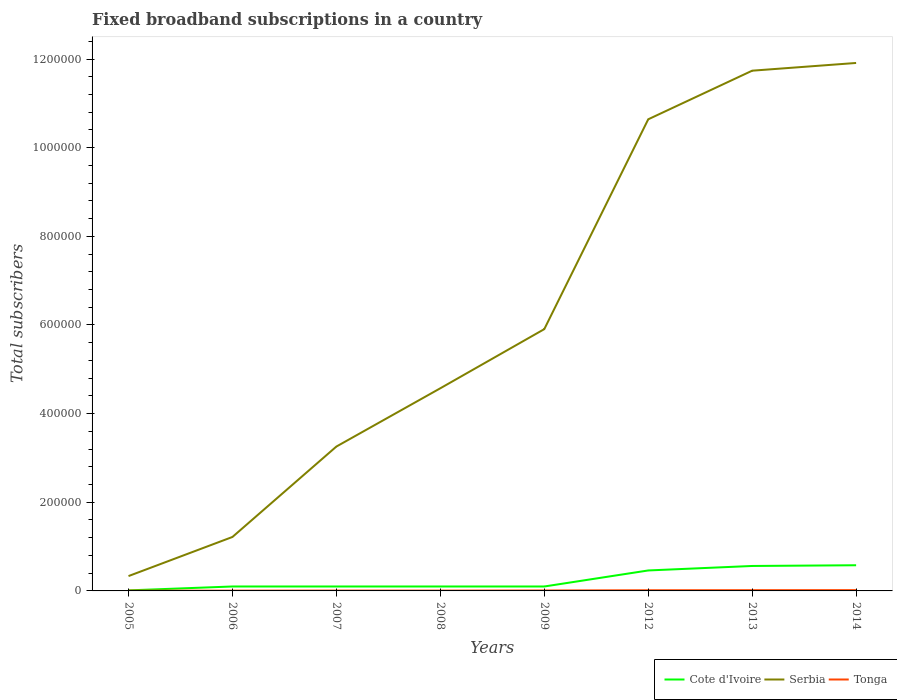How many different coloured lines are there?
Offer a terse response. 3. Across all years, what is the maximum number of broadband subscriptions in Cote d'Ivoire?
Ensure brevity in your answer.  1239. In which year was the number of broadband subscriptions in Tonga maximum?
Give a very brief answer. 2006. What is the total number of broadband subscriptions in Serbia in the graph?
Offer a very short reply. -7.16e+05. What is the difference between the highest and the second highest number of broadband subscriptions in Cote d'Ivoire?
Ensure brevity in your answer.  5.67e+04. What is the difference between the highest and the lowest number of broadband subscriptions in Serbia?
Make the answer very short. 3. How are the legend labels stacked?
Provide a succinct answer. Horizontal. What is the title of the graph?
Your answer should be very brief. Fixed broadband subscriptions in a country. What is the label or title of the Y-axis?
Give a very brief answer. Total subscribers. What is the Total subscribers of Cote d'Ivoire in 2005?
Provide a short and direct response. 1239. What is the Total subscribers in Serbia in 2005?
Provide a succinct answer. 3.35e+04. What is the Total subscribers of Tonga in 2005?
Offer a very short reply. 645. What is the Total subscribers of Cote d'Ivoire in 2006?
Give a very brief answer. 10000. What is the Total subscribers in Serbia in 2006?
Your answer should be very brief. 1.22e+05. What is the Total subscribers of Tonga in 2006?
Give a very brief answer. 633. What is the Total subscribers in Cote d'Ivoire in 2007?
Offer a very short reply. 10000. What is the Total subscribers in Serbia in 2007?
Your response must be concise. 3.26e+05. What is the Total subscribers in Tonga in 2007?
Your response must be concise. 780. What is the Total subscribers of Serbia in 2008?
Keep it short and to the point. 4.57e+05. What is the Total subscribers in Tonga in 2008?
Make the answer very short. 721. What is the Total subscribers of Serbia in 2009?
Your response must be concise. 5.91e+05. What is the Total subscribers in Tonga in 2009?
Make the answer very short. 1000. What is the Total subscribers in Cote d'Ivoire in 2012?
Your answer should be compact. 4.62e+04. What is the Total subscribers in Serbia in 2012?
Your response must be concise. 1.06e+06. What is the Total subscribers of Tonga in 2012?
Offer a very short reply. 1500. What is the Total subscribers in Cote d'Ivoire in 2013?
Give a very brief answer. 5.63e+04. What is the Total subscribers of Serbia in 2013?
Ensure brevity in your answer.  1.17e+06. What is the Total subscribers in Tonga in 2013?
Provide a succinct answer. 1700. What is the Total subscribers of Cote d'Ivoire in 2014?
Make the answer very short. 5.79e+04. What is the Total subscribers in Serbia in 2014?
Provide a short and direct response. 1.19e+06. What is the Total subscribers of Tonga in 2014?
Your answer should be compact. 1800. Across all years, what is the maximum Total subscribers in Cote d'Ivoire?
Your response must be concise. 5.79e+04. Across all years, what is the maximum Total subscribers in Serbia?
Ensure brevity in your answer.  1.19e+06. Across all years, what is the maximum Total subscribers in Tonga?
Give a very brief answer. 1800. Across all years, what is the minimum Total subscribers in Cote d'Ivoire?
Give a very brief answer. 1239. Across all years, what is the minimum Total subscribers in Serbia?
Provide a short and direct response. 3.35e+04. Across all years, what is the minimum Total subscribers in Tonga?
Your response must be concise. 633. What is the total Total subscribers of Cote d'Ivoire in the graph?
Keep it short and to the point. 2.02e+05. What is the total Total subscribers of Serbia in the graph?
Keep it short and to the point. 4.96e+06. What is the total Total subscribers in Tonga in the graph?
Ensure brevity in your answer.  8779. What is the difference between the Total subscribers of Cote d'Ivoire in 2005 and that in 2006?
Provide a succinct answer. -8761. What is the difference between the Total subscribers in Serbia in 2005 and that in 2006?
Your answer should be compact. -8.82e+04. What is the difference between the Total subscribers in Cote d'Ivoire in 2005 and that in 2007?
Keep it short and to the point. -8761. What is the difference between the Total subscribers in Serbia in 2005 and that in 2007?
Your response must be concise. -2.92e+05. What is the difference between the Total subscribers in Tonga in 2005 and that in 2007?
Your answer should be compact. -135. What is the difference between the Total subscribers in Cote d'Ivoire in 2005 and that in 2008?
Offer a very short reply. -8761. What is the difference between the Total subscribers of Serbia in 2005 and that in 2008?
Ensure brevity in your answer.  -4.24e+05. What is the difference between the Total subscribers of Tonga in 2005 and that in 2008?
Keep it short and to the point. -76. What is the difference between the Total subscribers in Cote d'Ivoire in 2005 and that in 2009?
Your answer should be very brief. -8761. What is the difference between the Total subscribers in Serbia in 2005 and that in 2009?
Your answer should be very brief. -5.57e+05. What is the difference between the Total subscribers in Tonga in 2005 and that in 2009?
Provide a succinct answer. -355. What is the difference between the Total subscribers of Cote d'Ivoire in 2005 and that in 2012?
Provide a short and direct response. -4.49e+04. What is the difference between the Total subscribers of Serbia in 2005 and that in 2012?
Keep it short and to the point. -1.03e+06. What is the difference between the Total subscribers of Tonga in 2005 and that in 2012?
Provide a short and direct response. -855. What is the difference between the Total subscribers in Cote d'Ivoire in 2005 and that in 2013?
Your answer should be compact. -5.50e+04. What is the difference between the Total subscribers in Serbia in 2005 and that in 2013?
Provide a succinct answer. -1.14e+06. What is the difference between the Total subscribers of Tonga in 2005 and that in 2013?
Provide a short and direct response. -1055. What is the difference between the Total subscribers in Cote d'Ivoire in 2005 and that in 2014?
Give a very brief answer. -5.67e+04. What is the difference between the Total subscribers in Serbia in 2005 and that in 2014?
Your response must be concise. -1.16e+06. What is the difference between the Total subscribers of Tonga in 2005 and that in 2014?
Offer a very short reply. -1155. What is the difference between the Total subscribers of Serbia in 2006 and that in 2007?
Your answer should be compact. -2.04e+05. What is the difference between the Total subscribers of Tonga in 2006 and that in 2007?
Keep it short and to the point. -147. What is the difference between the Total subscribers in Cote d'Ivoire in 2006 and that in 2008?
Offer a terse response. 0. What is the difference between the Total subscribers in Serbia in 2006 and that in 2008?
Give a very brief answer. -3.35e+05. What is the difference between the Total subscribers of Tonga in 2006 and that in 2008?
Offer a terse response. -88. What is the difference between the Total subscribers of Serbia in 2006 and that in 2009?
Make the answer very short. -4.69e+05. What is the difference between the Total subscribers of Tonga in 2006 and that in 2009?
Your answer should be very brief. -367. What is the difference between the Total subscribers of Cote d'Ivoire in 2006 and that in 2012?
Provide a succinct answer. -3.62e+04. What is the difference between the Total subscribers of Serbia in 2006 and that in 2012?
Your response must be concise. -9.42e+05. What is the difference between the Total subscribers of Tonga in 2006 and that in 2012?
Give a very brief answer. -867. What is the difference between the Total subscribers in Cote d'Ivoire in 2006 and that in 2013?
Offer a terse response. -4.63e+04. What is the difference between the Total subscribers in Serbia in 2006 and that in 2013?
Make the answer very short. -1.05e+06. What is the difference between the Total subscribers of Tonga in 2006 and that in 2013?
Your answer should be very brief. -1067. What is the difference between the Total subscribers of Cote d'Ivoire in 2006 and that in 2014?
Your answer should be compact. -4.79e+04. What is the difference between the Total subscribers in Serbia in 2006 and that in 2014?
Provide a short and direct response. -1.07e+06. What is the difference between the Total subscribers in Tonga in 2006 and that in 2014?
Your response must be concise. -1167. What is the difference between the Total subscribers in Serbia in 2007 and that in 2008?
Make the answer very short. -1.31e+05. What is the difference between the Total subscribers in Cote d'Ivoire in 2007 and that in 2009?
Your response must be concise. 0. What is the difference between the Total subscribers of Serbia in 2007 and that in 2009?
Give a very brief answer. -2.65e+05. What is the difference between the Total subscribers of Tonga in 2007 and that in 2009?
Keep it short and to the point. -220. What is the difference between the Total subscribers in Cote d'Ivoire in 2007 and that in 2012?
Offer a very short reply. -3.62e+04. What is the difference between the Total subscribers in Serbia in 2007 and that in 2012?
Provide a succinct answer. -7.38e+05. What is the difference between the Total subscribers of Tonga in 2007 and that in 2012?
Make the answer very short. -720. What is the difference between the Total subscribers in Cote d'Ivoire in 2007 and that in 2013?
Give a very brief answer. -4.63e+04. What is the difference between the Total subscribers of Serbia in 2007 and that in 2013?
Your answer should be very brief. -8.48e+05. What is the difference between the Total subscribers of Tonga in 2007 and that in 2013?
Offer a terse response. -920. What is the difference between the Total subscribers in Cote d'Ivoire in 2007 and that in 2014?
Your answer should be compact. -4.79e+04. What is the difference between the Total subscribers of Serbia in 2007 and that in 2014?
Provide a succinct answer. -8.65e+05. What is the difference between the Total subscribers of Tonga in 2007 and that in 2014?
Make the answer very short. -1020. What is the difference between the Total subscribers in Serbia in 2008 and that in 2009?
Ensure brevity in your answer.  -1.33e+05. What is the difference between the Total subscribers of Tonga in 2008 and that in 2009?
Your answer should be compact. -279. What is the difference between the Total subscribers in Cote d'Ivoire in 2008 and that in 2012?
Make the answer very short. -3.62e+04. What is the difference between the Total subscribers of Serbia in 2008 and that in 2012?
Keep it short and to the point. -6.07e+05. What is the difference between the Total subscribers in Tonga in 2008 and that in 2012?
Your answer should be compact. -779. What is the difference between the Total subscribers in Cote d'Ivoire in 2008 and that in 2013?
Keep it short and to the point. -4.63e+04. What is the difference between the Total subscribers of Serbia in 2008 and that in 2013?
Give a very brief answer. -7.16e+05. What is the difference between the Total subscribers of Tonga in 2008 and that in 2013?
Ensure brevity in your answer.  -979. What is the difference between the Total subscribers of Cote d'Ivoire in 2008 and that in 2014?
Ensure brevity in your answer.  -4.79e+04. What is the difference between the Total subscribers in Serbia in 2008 and that in 2014?
Give a very brief answer. -7.34e+05. What is the difference between the Total subscribers of Tonga in 2008 and that in 2014?
Give a very brief answer. -1079. What is the difference between the Total subscribers of Cote d'Ivoire in 2009 and that in 2012?
Offer a very short reply. -3.62e+04. What is the difference between the Total subscribers of Serbia in 2009 and that in 2012?
Make the answer very short. -4.73e+05. What is the difference between the Total subscribers of Tonga in 2009 and that in 2012?
Provide a succinct answer. -500. What is the difference between the Total subscribers of Cote d'Ivoire in 2009 and that in 2013?
Provide a short and direct response. -4.63e+04. What is the difference between the Total subscribers of Serbia in 2009 and that in 2013?
Your answer should be compact. -5.83e+05. What is the difference between the Total subscribers in Tonga in 2009 and that in 2013?
Offer a very short reply. -700. What is the difference between the Total subscribers of Cote d'Ivoire in 2009 and that in 2014?
Ensure brevity in your answer.  -4.79e+04. What is the difference between the Total subscribers in Serbia in 2009 and that in 2014?
Your answer should be compact. -6.00e+05. What is the difference between the Total subscribers of Tonga in 2009 and that in 2014?
Your response must be concise. -800. What is the difference between the Total subscribers in Cote d'Ivoire in 2012 and that in 2013?
Your response must be concise. -1.01e+04. What is the difference between the Total subscribers in Serbia in 2012 and that in 2013?
Provide a short and direct response. -1.10e+05. What is the difference between the Total subscribers in Tonga in 2012 and that in 2013?
Give a very brief answer. -200. What is the difference between the Total subscribers of Cote d'Ivoire in 2012 and that in 2014?
Offer a very short reply. -1.17e+04. What is the difference between the Total subscribers of Serbia in 2012 and that in 2014?
Offer a very short reply. -1.27e+05. What is the difference between the Total subscribers of Tonga in 2012 and that in 2014?
Provide a succinct answer. -300. What is the difference between the Total subscribers of Cote d'Ivoire in 2013 and that in 2014?
Provide a short and direct response. -1633. What is the difference between the Total subscribers of Serbia in 2013 and that in 2014?
Your response must be concise. -1.74e+04. What is the difference between the Total subscribers in Tonga in 2013 and that in 2014?
Your answer should be very brief. -100. What is the difference between the Total subscribers in Cote d'Ivoire in 2005 and the Total subscribers in Serbia in 2006?
Your answer should be compact. -1.20e+05. What is the difference between the Total subscribers in Cote d'Ivoire in 2005 and the Total subscribers in Tonga in 2006?
Offer a very short reply. 606. What is the difference between the Total subscribers in Serbia in 2005 and the Total subscribers in Tonga in 2006?
Offer a terse response. 3.29e+04. What is the difference between the Total subscribers of Cote d'Ivoire in 2005 and the Total subscribers of Serbia in 2007?
Keep it short and to the point. -3.24e+05. What is the difference between the Total subscribers of Cote d'Ivoire in 2005 and the Total subscribers of Tonga in 2007?
Offer a terse response. 459. What is the difference between the Total subscribers of Serbia in 2005 and the Total subscribers of Tonga in 2007?
Your answer should be very brief. 3.27e+04. What is the difference between the Total subscribers of Cote d'Ivoire in 2005 and the Total subscribers of Serbia in 2008?
Give a very brief answer. -4.56e+05. What is the difference between the Total subscribers in Cote d'Ivoire in 2005 and the Total subscribers in Tonga in 2008?
Your response must be concise. 518. What is the difference between the Total subscribers of Serbia in 2005 and the Total subscribers of Tonga in 2008?
Ensure brevity in your answer.  3.28e+04. What is the difference between the Total subscribers of Cote d'Ivoire in 2005 and the Total subscribers of Serbia in 2009?
Make the answer very short. -5.89e+05. What is the difference between the Total subscribers of Cote d'Ivoire in 2005 and the Total subscribers of Tonga in 2009?
Offer a terse response. 239. What is the difference between the Total subscribers of Serbia in 2005 and the Total subscribers of Tonga in 2009?
Provide a short and direct response. 3.25e+04. What is the difference between the Total subscribers of Cote d'Ivoire in 2005 and the Total subscribers of Serbia in 2012?
Offer a very short reply. -1.06e+06. What is the difference between the Total subscribers in Cote d'Ivoire in 2005 and the Total subscribers in Tonga in 2012?
Offer a terse response. -261. What is the difference between the Total subscribers of Serbia in 2005 and the Total subscribers of Tonga in 2012?
Your answer should be very brief. 3.20e+04. What is the difference between the Total subscribers in Cote d'Ivoire in 2005 and the Total subscribers in Serbia in 2013?
Your response must be concise. -1.17e+06. What is the difference between the Total subscribers in Cote d'Ivoire in 2005 and the Total subscribers in Tonga in 2013?
Offer a terse response. -461. What is the difference between the Total subscribers of Serbia in 2005 and the Total subscribers of Tonga in 2013?
Your answer should be very brief. 3.18e+04. What is the difference between the Total subscribers in Cote d'Ivoire in 2005 and the Total subscribers in Serbia in 2014?
Provide a short and direct response. -1.19e+06. What is the difference between the Total subscribers of Cote d'Ivoire in 2005 and the Total subscribers of Tonga in 2014?
Make the answer very short. -561. What is the difference between the Total subscribers of Serbia in 2005 and the Total subscribers of Tonga in 2014?
Give a very brief answer. 3.17e+04. What is the difference between the Total subscribers in Cote d'Ivoire in 2006 and the Total subscribers in Serbia in 2007?
Your response must be concise. -3.16e+05. What is the difference between the Total subscribers of Cote d'Ivoire in 2006 and the Total subscribers of Tonga in 2007?
Your response must be concise. 9220. What is the difference between the Total subscribers in Serbia in 2006 and the Total subscribers in Tonga in 2007?
Your response must be concise. 1.21e+05. What is the difference between the Total subscribers in Cote d'Ivoire in 2006 and the Total subscribers in Serbia in 2008?
Your answer should be very brief. -4.47e+05. What is the difference between the Total subscribers of Cote d'Ivoire in 2006 and the Total subscribers of Tonga in 2008?
Ensure brevity in your answer.  9279. What is the difference between the Total subscribers of Serbia in 2006 and the Total subscribers of Tonga in 2008?
Keep it short and to the point. 1.21e+05. What is the difference between the Total subscribers in Cote d'Ivoire in 2006 and the Total subscribers in Serbia in 2009?
Provide a succinct answer. -5.81e+05. What is the difference between the Total subscribers in Cote d'Ivoire in 2006 and the Total subscribers in Tonga in 2009?
Offer a terse response. 9000. What is the difference between the Total subscribers in Serbia in 2006 and the Total subscribers in Tonga in 2009?
Offer a very short reply. 1.21e+05. What is the difference between the Total subscribers of Cote d'Ivoire in 2006 and the Total subscribers of Serbia in 2012?
Make the answer very short. -1.05e+06. What is the difference between the Total subscribers in Cote d'Ivoire in 2006 and the Total subscribers in Tonga in 2012?
Your answer should be very brief. 8500. What is the difference between the Total subscribers of Serbia in 2006 and the Total subscribers of Tonga in 2012?
Keep it short and to the point. 1.20e+05. What is the difference between the Total subscribers in Cote d'Ivoire in 2006 and the Total subscribers in Serbia in 2013?
Offer a terse response. -1.16e+06. What is the difference between the Total subscribers in Cote d'Ivoire in 2006 and the Total subscribers in Tonga in 2013?
Keep it short and to the point. 8300. What is the difference between the Total subscribers of Serbia in 2006 and the Total subscribers of Tonga in 2013?
Offer a terse response. 1.20e+05. What is the difference between the Total subscribers in Cote d'Ivoire in 2006 and the Total subscribers in Serbia in 2014?
Provide a succinct answer. -1.18e+06. What is the difference between the Total subscribers in Cote d'Ivoire in 2006 and the Total subscribers in Tonga in 2014?
Provide a short and direct response. 8200. What is the difference between the Total subscribers of Serbia in 2006 and the Total subscribers of Tonga in 2014?
Give a very brief answer. 1.20e+05. What is the difference between the Total subscribers of Cote d'Ivoire in 2007 and the Total subscribers of Serbia in 2008?
Your answer should be very brief. -4.47e+05. What is the difference between the Total subscribers in Cote d'Ivoire in 2007 and the Total subscribers in Tonga in 2008?
Provide a succinct answer. 9279. What is the difference between the Total subscribers in Serbia in 2007 and the Total subscribers in Tonga in 2008?
Your answer should be very brief. 3.25e+05. What is the difference between the Total subscribers of Cote d'Ivoire in 2007 and the Total subscribers of Serbia in 2009?
Make the answer very short. -5.81e+05. What is the difference between the Total subscribers of Cote d'Ivoire in 2007 and the Total subscribers of Tonga in 2009?
Your response must be concise. 9000. What is the difference between the Total subscribers in Serbia in 2007 and the Total subscribers in Tonga in 2009?
Give a very brief answer. 3.25e+05. What is the difference between the Total subscribers in Cote d'Ivoire in 2007 and the Total subscribers in Serbia in 2012?
Offer a very short reply. -1.05e+06. What is the difference between the Total subscribers in Cote d'Ivoire in 2007 and the Total subscribers in Tonga in 2012?
Your answer should be compact. 8500. What is the difference between the Total subscribers of Serbia in 2007 and the Total subscribers of Tonga in 2012?
Your response must be concise. 3.24e+05. What is the difference between the Total subscribers of Cote d'Ivoire in 2007 and the Total subscribers of Serbia in 2013?
Ensure brevity in your answer.  -1.16e+06. What is the difference between the Total subscribers of Cote d'Ivoire in 2007 and the Total subscribers of Tonga in 2013?
Provide a succinct answer. 8300. What is the difference between the Total subscribers in Serbia in 2007 and the Total subscribers in Tonga in 2013?
Your answer should be compact. 3.24e+05. What is the difference between the Total subscribers of Cote d'Ivoire in 2007 and the Total subscribers of Serbia in 2014?
Your answer should be compact. -1.18e+06. What is the difference between the Total subscribers of Cote d'Ivoire in 2007 and the Total subscribers of Tonga in 2014?
Ensure brevity in your answer.  8200. What is the difference between the Total subscribers in Serbia in 2007 and the Total subscribers in Tonga in 2014?
Provide a succinct answer. 3.24e+05. What is the difference between the Total subscribers in Cote d'Ivoire in 2008 and the Total subscribers in Serbia in 2009?
Keep it short and to the point. -5.81e+05. What is the difference between the Total subscribers in Cote d'Ivoire in 2008 and the Total subscribers in Tonga in 2009?
Give a very brief answer. 9000. What is the difference between the Total subscribers of Serbia in 2008 and the Total subscribers of Tonga in 2009?
Ensure brevity in your answer.  4.56e+05. What is the difference between the Total subscribers of Cote d'Ivoire in 2008 and the Total subscribers of Serbia in 2012?
Provide a short and direct response. -1.05e+06. What is the difference between the Total subscribers in Cote d'Ivoire in 2008 and the Total subscribers in Tonga in 2012?
Provide a succinct answer. 8500. What is the difference between the Total subscribers of Serbia in 2008 and the Total subscribers of Tonga in 2012?
Offer a very short reply. 4.56e+05. What is the difference between the Total subscribers in Cote d'Ivoire in 2008 and the Total subscribers in Serbia in 2013?
Ensure brevity in your answer.  -1.16e+06. What is the difference between the Total subscribers in Cote d'Ivoire in 2008 and the Total subscribers in Tonga in 2013?
Offer a terse response. 8300. What is the difference between the Total subscribers in Serbia in 2008 and the Total subscribers in Tonga in 2013?
Give a very brief answer. 4.55e+05. What is the difference between the Total subscribers in Cote d'Ivoire in 2008 and the Total subscribers in Serbia in 2014?
Your response must be concise. -1.18e+06. What is the difference between the Total subscribers of Cote d'Ivoire in 2008 and the Total subscribers of Tonga in 2014?
Your answer should be very brief. 8200. What is the difference between the Total subscribers of Serbia in 2008 and the Total subscribers of Tonga in 2014?
Your answer should be compact. 4.55e+05. What is the difference between the Total subscribers of Cote d'Ivoire in 2009 and the Total subscribers of Serbia in 2012?
Ensure brevity in your answer.  -1.05e+06. What is the difference between the Total subscribers of Cote d'Ivoire in 2009 and the Total subscribers of Tonga in 2012?
Provide a succinct answer. 8500. What is the difference between the Total subscribers in Serbia in 2009 and the Total subscribers in Tonga in 2012?
Give a very brief answer. 5.89e+05. What is the difference between the Total subscribers in Cote d'Ivoire in 2009 and the Total subscribers in Serbia in 2013?
Give a very brief answer. -1.16e+06. What is the difference between the Total subscribers in Cote d'Ivoire in 2009 and the Total subscribers in Tonga in 2013?
Your response must be concise. 8300. What is the difference between the Total subscribers in Serbia in 2009 and the Total subscribers in Tonga in 2013?
Provide a succinct answer. 5.89e+05. What is the difference between the Total subscribers of Cote d'Ivoire in 2009 and the Total subscribers of Serbia in 2014?
Offer a very short reply. -1.18e+06. What is the difference between the Total subscribers in Cote d'Ivoire in 2009 and the Total subscribers in Tonga in 2014?
Offer a terse response. 8200. What is the difference between the Total subscribers in Serbia in 2009 and the Total subscribers in Tonga in 2014?
Your response must be concise. 5.89e+05. What is the difference between the Total subscribers in Cote d'Ivoire in 2012 and the Total subscribers in Serbia in 2013?
Make the answer very short. -1.13e+06. What is the difference between the Total subscribers in Cote d'Ivoire in 2012 and the Total subscribers in Tonga in 2013?
Your answer should be very brief. 4.45e+04. What is the difference between the Total subscribers in Serbia in 2012 and the Total subscribers in Tonga in 2013?
Your answer should be compact. 1.06e+06. What is the difference between the Total subscribers in Cote d'Ivoire in 2012 and the Total subscribers in Serbia in 2014?
Offer a terse response. -1.14e+06. What is the difference between the Total subscribers in Cote d'Ivoire in 2012 and the Total subscribers in Tonga in 2014?
Ensure brevity in your answer.  4.44e+04. What is the difference between the Total subscribers of Serbia in 2012 and the Total subscribers of Tonga in 2014?
Offer a very short reply. 1.06e+06. What is the difference between the Total subscribers in Cote d'Ivoire in 2013 and the Total subscribers in Serbia in 2014?
Offer a terse response. -1.13e+06. What is the difference between the Total subscribers in Cote d'Ivoire in 2013 and the Total subscribers in Tonga in 2014?
Provide a short and direct response. 5.45e+04. What is the difference between the Total subscribers in Serbia in 2013 and the Total subscribers in Tonga in 2014?
Give a very brief answer. 1.17e+06. What is the average Total subscribers of Cote d'Ivoire per year?
Offer a very short reply. 2.52e+04. What is the average Total subscribers in Serbia per year?
Make the answer very short. 6.20e+05. What is the average Total subscribers of Tonga per year?
Your response must be concise. 1097.38. In the year 2005, what is the difference between the Total subscribers in Cote d'Ivoire and Total subscribers in Serbia?
Your answer should be very brief. -3.22e+04. In the year 2005, what is the difference between the Total subscribers of Cote d'Ivoire and Total subscribers of Tonga?
Give a very brief answer. 594. In the year 2005, what is the difference between the Total subscribers in Serbia and Total subscribers in Tonga?
Offer a terse response. 3.28e+04. In the year 2006, what is the difference between the Total subscribers in Cote d'Ivoire and Total subscribers in Serbia?
Offer a very short reply. -1.12e+05. In the year 2006, what is the difference between the Total subscribers in Cote d'Ivoire and Total subscribers in Tonga?
Your answer should be compact. 9367. In the year 2006, what is the difference between the Total subscribers in Serbia and Total subscribers in Tonga?
Give a very brief answer. 1.21e+05. In the year 2007, what is the difference between the Total subscribers in Cote d'Ivoire and Total subscribers in Serbia?
Your answer should be compact. -3.16e+05. In the year 2007, what is the difference between the Total subscribers in Cote d'Ivoire and Total subscribers in Tonga?
Provide a succinct answer. 9220. In the year 2007, what is the difference between the Total subscribers of Serbia and Total subscribers of Tonga?
Keep it short and to the point. 3.25e+05. In the year 2008, what is the difference between the Total subscribers of Cote d'Ivoire and Total subscribers of Serbia?
Provide a succinct answer. -4.47e+05. In the year 2008, what is the difference between the Total subscribers in Cote d'Ivoire and Total subscribers in Tonga?
Your response must be concise. 9279. In the year 2008, what is the difference between the Total subscribers of Serbia and Total subscribers of Tonga?
Provide a short and direct response. 4.56e+05. In the year 2009, what is the difference between the Total subscribers in Cote d'Ivoire and Total subscribers in Serbia?
Your answer should be very brief. -5.81e+05. In the year 2009, what is the difference between the Total subscribers in Cote d'Ivoire and Total subscribers in Tonga?
Make the answer very short. 9000. In the year 2009, what is the difference between the Total subscribers in Serbia and Total subscribers in Tonga?
Your answer should be compact. 5.90e+05. In the year 2012, what is the difference between the Total subscribers in Cote d'Ivoire and Total subscribers in Serbia?
Your answer should be very brief. -1.02e+06. In the year 2012, what is the difference between the Total subscribers in Cote d'Ivoire and Total subscribers in Tonga?
Offer a terse response. 4.47e+04. In the year 2012, what is the difference between the Total subscribers in Serbia and Total subscribers in Tonga?
Keep it short and to the point. 1.06e+06. In the year 2013, what is the difference between the Total subscribers in Cote d'Ivoire and Total subscribers in Serbia?
Your answer should be compact. -1.12e+06. In the year 2013, what is the difference between the Total subscribers in Cote d'Ivoire and Total subscribers in Tonga?
Keep it short and to the point. 5.46e+04. In the year 2013, what is the difference between the Total subscribers of Serbia and Total subscribers of Tonga?
Provide a short and direct response. 1.17e+06. In the year 2014, what is the difference between the Total subscribers in Cote d'Ivoire and Total subscribers in Serbia?
Offer a terse response. -1.13e+06. In the year 2014, what is the difference between the Total subscribers of Cote d'Ivoire and Total subscribers of Tonga?
Keep it short and to the point. 5.61e+04. In the year 2014, what is the difference between the Total subscribers of Serbia and Total subscribers of Tonga?
Make the answer very short. 1.19e+06. What is the ratio of the Total subscribers of Cote d'Ivoire in 2005 to that in 2006?
Provide a short and direct response. 0.12. What is the ratio of the Total subscribers of Serbia in 2005 to that in 2006?
Offer a terse response. 0.28. What is the ratio of the Total subscribers in Tonga in 2005 to that in 2006?
Your answer should be very brief. 1.02. What is the ratio of the Total subscribers in Cote d'Ivoire in 2005 to that in 2007?
Your answer should be compact. 0.12. What is the ratio of the Total subscribers in Serbia in 2005 to that in 2007?
Your answer should be compact. 0.1. What is the ratio of the Total subscribers of Tonga in 2005 to that in 2007?
Provide a succinct answer. 0.83. What is the ratio of the Total subscribers of Cote d'Ivoire in 2005 to that in 2008?
Keep it short and to the point. 0.12. What is the ratio of the Total subscribers in Serbia in 2005 to that in 2008?
Your response must be concise. 0.07. What is the ratio of the Total subscribers in Tonga in 2005 to that in 2008?
Provide a succinct answer. 0.89. What is the ratio of the Total subscribers of Cote d'Ivoire in 2005 to that in 2009?
Make the answer very short. 0.12. What is the ratio of the Total subscribers in Serbia in 2005 to that in 2009?
Offer a very short reply. 0.06. What is the ratio of the Total subscribers of Tonga in 2005 to that in 2009?
Give a very brief answer. 0.65. What is the ratio of the Total subscribers of Cote d'Ivoire in 2005 to that in 2012?
Offer a terse response. 0.03. What is the ratio of the Total subscribers of Serbia in 2005 to that in 2012?
Your response must be concise. 0.03. What is the ratio of the Total subscribers in Tonga in 2005 to that in 2012?
Offer a very short reply. 0.43. What is the ratio of the Total subscribers in Cote d'Ivoire in 2005 to that in 2013?
Give a very brief answer. 0.02. What is the ratio of the Total subscribers of Serbia in 2005 to that in 2013?
Keep it short and to the point. 0.03. What is the ratio of the Total subscribers in Tonga in 2005 to that in 2013?
Your response must be concise. 0.38. What is the ratio of the Total subscribers in Cote d'Ivoire in 2005 to that in 2014?
Give a very brief answer. 0.02. What is the ratio of the Total subscribers of Serbia in 2005 to that in 2014?
Your response must be concise. 0.03. What is the ratio of the Total subscribers of Tonga in 2005 to that in 2014?
Keep it short and to the point. 0.36. What is the ratio of the Total subscribers of Serbia in 2006 to that in 2007?
Provide a short and direct response. 0.37. What is the ratio of the Total subscribers in Tonga in 2006 to that in 2007?
Keep it short and to the point. 0.81. What is the ratio of the Total subscribers in Serbia in 2006 to that in 2008?
Your answer should be compact. 0.27. What is the ratio of the Total subscribers of Tonga in 2006 to that in 2008?
Offer a very short reply. 0.88. What is the ratio of the Total subscribers of Serbia in 2006 to that in 2009?
Give a very brief answer. 0.21. What is the ratio of the Total subscribers of Tonga in 2006 to that in 2009?
Keep it short and to the point. 0.63. What is the ratio of the Total subscribers of Cote d'Ivoire in 2006 to that in 2012?
Your answer should be very brief. 0.22. What is the ratio of the Total subscribers in Serbia in 2006 to that in 2012?
Offer a very short reply. 0.11. What is the ratio of the Total subscribers in Tonga in 2006 to that in 2012?
Give a very brief answer. 0.42. What is the ratio of the Total subscribers of Cote d'Ivoire in 2006 to that in 2013?
Provide a succinct answer. 0.18. What is the ratio of the Total subscribers in Serbia in 2006 to that in 2013?
Make the answer very short. 0.1. What is the ratio of the Total subscribers of Tonga in 2006 to that in 2013?
Give a very brief answer. 0.37. What is the ratio of the Total subscribers of Cote d'Ivoire in 2006 to that in 2014?
Provide a short and direct response. 0.17. What is the ratio of the Total subscribers in Serbia in 2006 to that in 2014?
Make the answer very short. 0.1. What is the ratio of the Total subscribers in Tonga in 2006 to that in 2014?
Offer a very short reply. 0.35. What is the ratio of the Total subscribers of Cote d'Ivoire in 2007 to that in 2008?
Offer a terse response. 1. What is the ratio of the Total subscribers of Serbia in 2007 to that in 2008?
Provide a short and direct response. 0.71. What is the ratio of the Total subscribers of Tonga in 2007 to that in 2008?
Your answer should be compact. 1.08. What is the ratio of the Total subscribers of Serbia in 2007 to that in 2009?
Provide a short and direct response. 0.55. What is the ratio of the Total subscribers of Tonga in 2007 to that in 2009?
Offer a terse response. 0.78. What is the ratio of the Total subscribers in Cote d'Ivoire in 2007 to that in 2012?
Keep it short and to the point. 0.22. What is the ratio of the Total subscribers of Serbia in 2007 to that in 2012?
Offer a very short reply. 0.31. What is the ratio of the Total subscribers in Tonga in 2007 to that in 2012?
Your answer should be very brief. 0.52. What is the ratio of the Total subscribers of Cote d'Ivoire in 2007 to that in 2013?
Your response must be concise. 0.18. What is the ratio of the Total subscribers in Serbia in 2007 to that in 2013?
Offer a very short reply. 0.28. What is the ratio of the Total subscribers of Tonga in 2007 to that in 2013?
Give a very brief answer. 0.46. What is the ratio of the Total subscribers of Cote d'Ivoire in 2007 to that in 2014?
Make the answer very short. 0.17. What is the ratio of the Total subscribers in Serbia in 2007 to that in 2014?
Provide a short and direct response. 0.27. What is the ratio of the Total subscribers of Tonga in 2007 to that in 2014?
Ensure brevity in your answer.  0.43. What is the ratio of the Total subscribers of Serbia in 2008 to that in 2009?
Ensure brevity in your answer.  0.77. What is the ratio of the Total subscribers of Tonga in 2008 to that in 2009?
Ensure brevity in your answer.  0.72. What is the ratio of the Total subscribers in Cote d'Ivoire in 2008 to that in 2012?
Your response must be concise. 0.22. What is the ratio of the Total subscribers in Serbia in 2008 to that in 2012?
Provide a short and direct response. 0.43. What is the ratio of the Total subscribers in Tonga in 2008 to that in 2012?
Ensure brevity in your answer.  0.48. What is the ratio of the Total subscribers of Cote d'Ivoire in 2008 to that in 2013?
Your answer should be compact. 0.18. What is the ratio of the Total subscribers in Serbia in 2008 to that in 2013?
Offer a very short reply. 0.39. What is the ratio of the Total subscribers of Tonga in 2008 to that in 2013?
Your response must be concise. 0.42. What is the ratio of the Total subscribers of Cote d'Ivoire in 2008 to that in 2014?
Provide a short and direct response. 0.17. What is the ratio of the Total subscribers in Serbia in 2008 to that in 2014?
Offer a terse response. 0.38. What is the ratio of the Total subscribers in Tonga in 2008 to that in 2014?
Your response must be concise. 0.4. What is the ratio of the Total subscribers of Cote d'Ivoire in 2009 to that in 2012?
Ensure brevity in your answer.  0.22. What is the ratio of the Total subscribers of Serbia in 2009 to that in 2012?
Your answer should be compact. 0.56. What is the ratio of the Total subscribers in Tonga in 2009 to that in 2012?
Ensure brevity in your answer.  0.67. What is the ratio of the Total subscribers in Cote d'Ivoire in 2009 to that in 2013?
Provide a succinct answer. 0.18. What is the ratio of the Total subscribers of Serbia in 2009 to that in 2013?
Your answer should be very brief. 0.5. What is the ratio of the Total subscribers of Tonga in 2009 to that in 2013?
Provide a succinct answer. 0.59. What is the ratio of the Total subscribers of Cote d'Ivoire in 2009 to that in 2014?
Keep it short and to the point. 0.17. What is the ratio of the Total subscribers of Serbia in 2009 to that in 2014?
Keep it short and to the point. 0.5. What is the ratio of the Total subscribers of Tonga in 2009 to that in 2014?
Your answer should be very brief. 0.56. What is the ratio of the Total subscribers in Cote d'Ivoire in 2012 to that in 2013?
Ensure brevity in your answer.  0.82. What is the ratio of the Total subscribers of Serbia in 2012 to that in 2013?
Keep it short and to the point. 0.91. What is the ratio of the Total subscribers in Tonga in 2012 to that in 2013?
Your answer should be compact. 0.88. What is the ratio of the Total subscribers in Cote d'Ivoire in 2012 to that in 2014?
Offer a terse response. 0.8. What is the ratio of the Total subscribers of Serbia in 2012 to that in 2014?
Keep it short and to the point. 0.89. What is the ratio of the Total subscribers of Cote d'Ivoire in 2013 to that in 2014?
Your answer should be compact. 0.97. What is the ratio of the Total subscribers of Serbia in 2013 to that in 2014?
Give a very brief answer. 0.99. What is the ratio of the Total subscribers in Tonga in 2013 to that in 2014?
Make the answer very short. 0.94. What is the difference between the highest and the second highest Total subscribers in Cote d'Ivoire?
Ensure brevity in your answer.  1633. What is the difference between the highest and the second highest Total subscribers in Serbia?
Keep it short and to the point. 1.74e+04. What is the difference between the highest and the second highest Total subscribers of Tonga?
Your answer should be compact. 100. What is the difference between the highest and the lowest Total subscribers of Cote d'Ivoire?
Your response must be concise. 5.67e+04. What is the difference between the highest and the lowest Total subscribers in Serbia?
Provide a short and direct response. 1.16e+06. What is the difference between the highest and the lowest Total subscribers of Tonga?
Ensure brevity in your answer.  1167. 